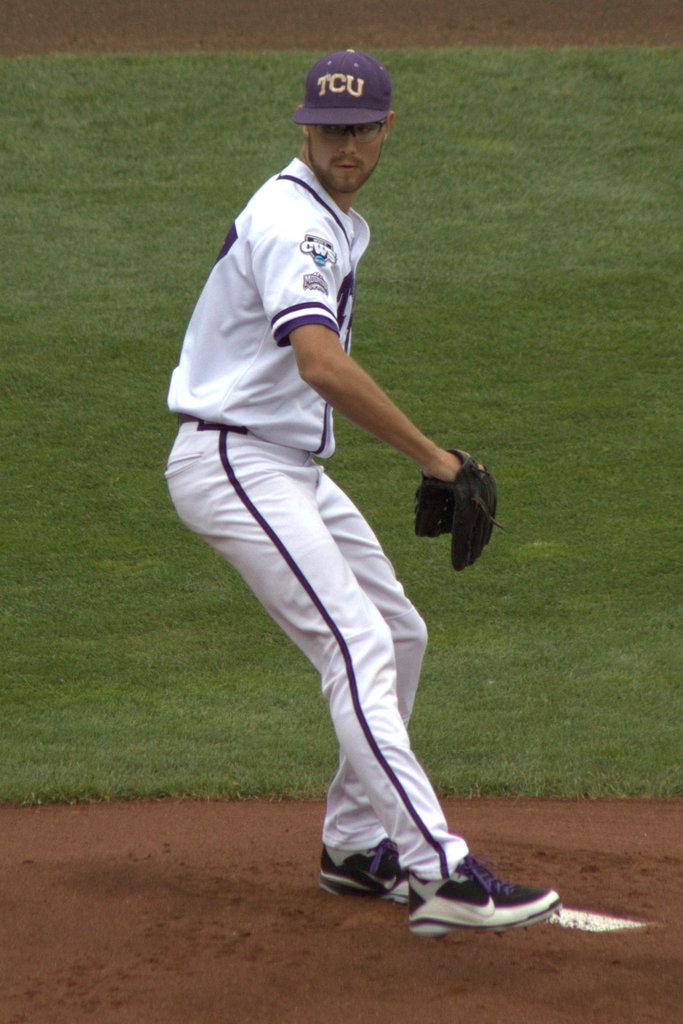What team does he pitch for?
Give a very brief answer. Tcu. 